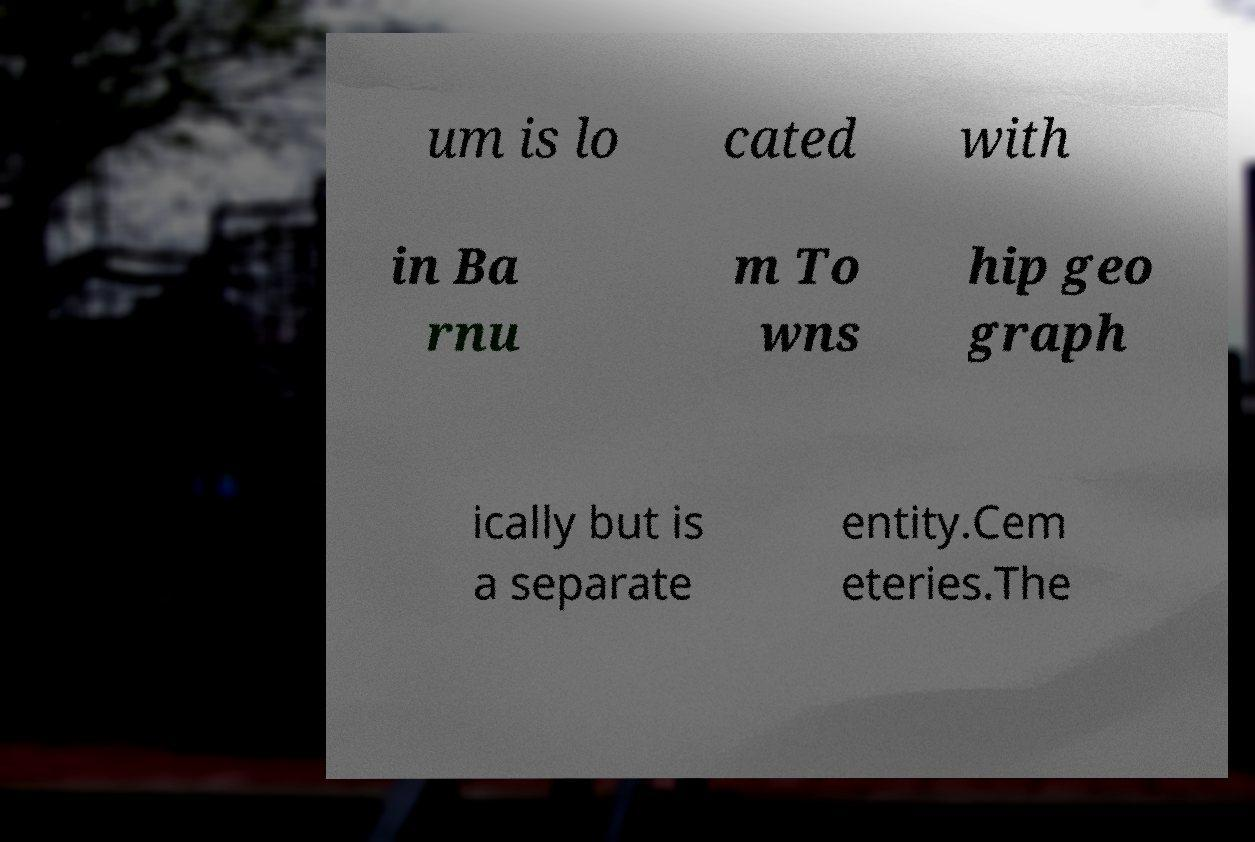For documentation purposes, I need the text within this image transcribed. Could you provide that? um is lo cated with in Ba rnu m To wns hip geo graph ically but is a separate entity.Cem eteries.The 